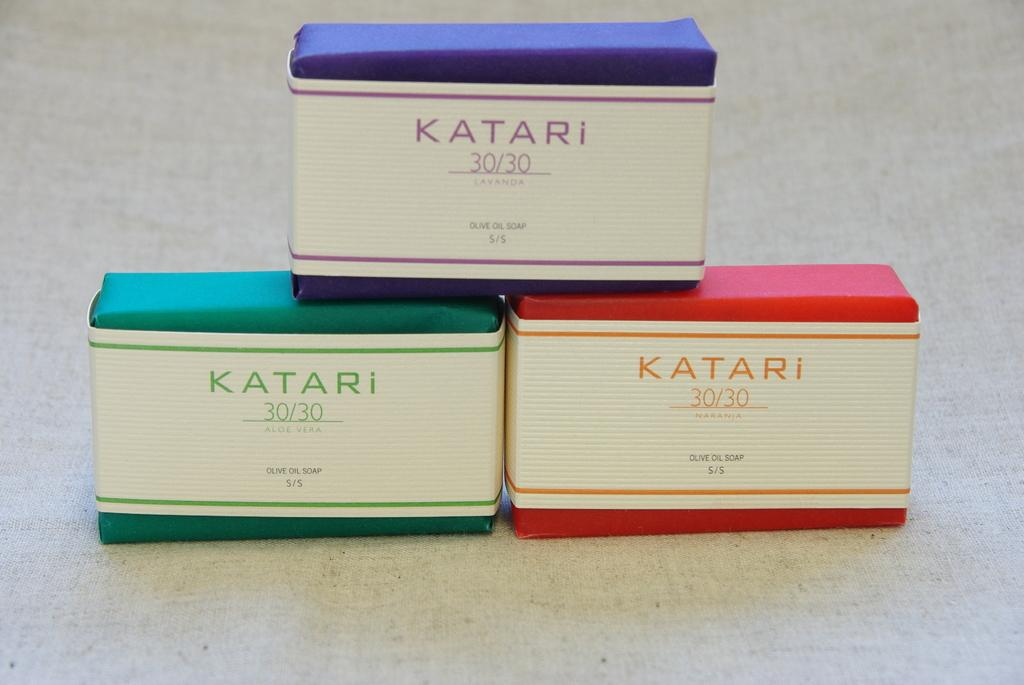Provide a one-sentence caption for the provided image. A product named Katari has a 30/30 concentration. 